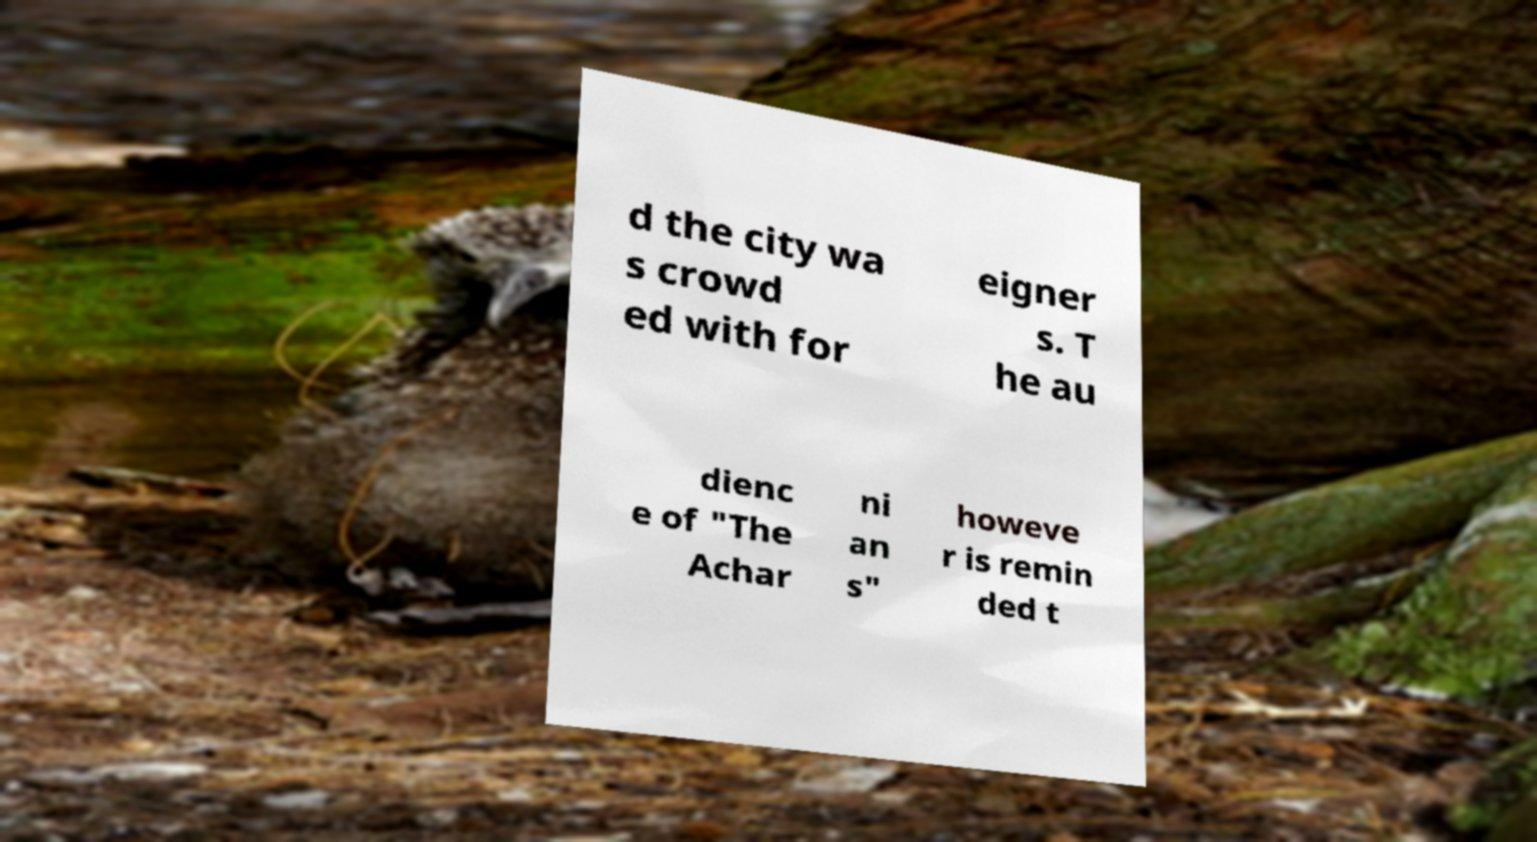Can you read and provide the text displayed in the image?This photo seems to have some interesting text. Can you extract and type it out for me? d the city wa s crowd ed with for eigner s. T he au dienc e of "The Achar ni an s" howeve r is remin ded t 